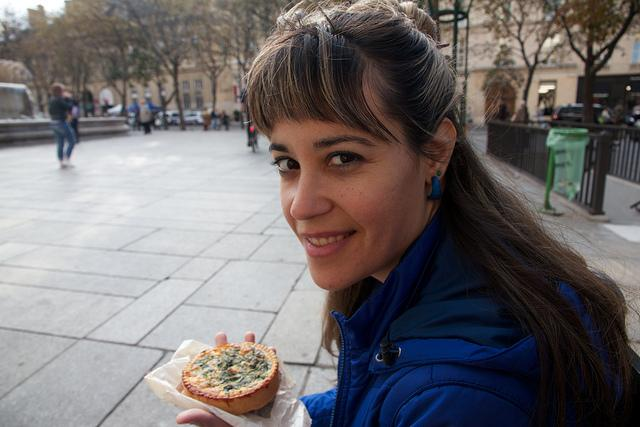What is matching the color of her jacket?

Choices:
A) hair
B) eyebrows
C) earrings
D) lipstick earrings 